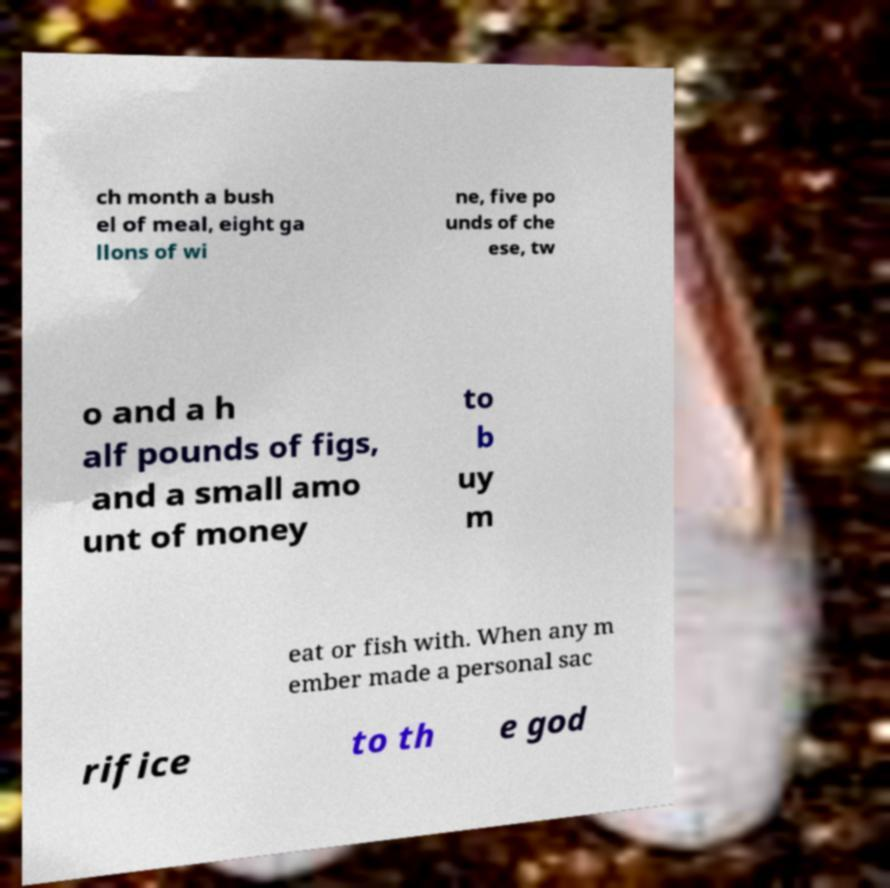For documentation purposes, I need the text within this image transcribed. Could you provide that? ch month a bush el of meal, eight ga llons of wi ne, five po unds of che ese, tw o and a h alf pounds of figs, and a small amo unt of money to b uy m eat or fish with. When any m ember made a personal sac rifice to th e god 